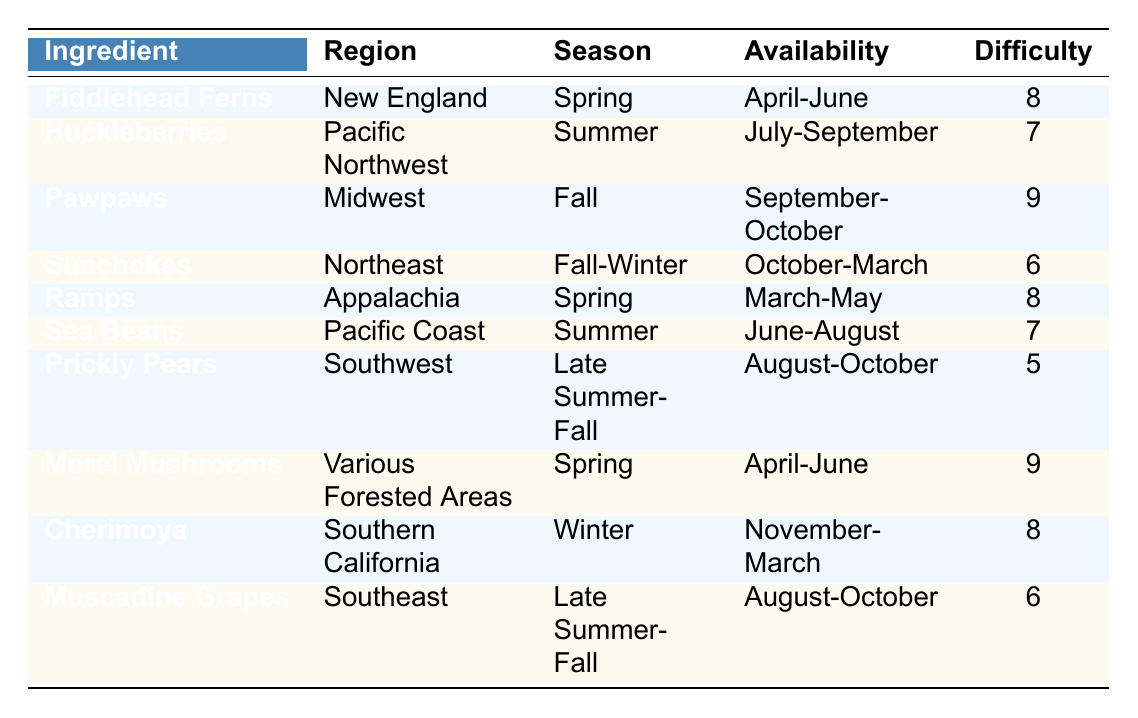What is the season for Fiddlehead Ferns? According to the table, Fiddlehead Ferns are in season in the Spring.
Answer: Spring During which months are Huckleberries available? The table states that Huckleberries are available from July to September.
Answer: July-September What region is associated with Pawpaws? The table specifies the region for Pawpaws as the Midwest.
Answer: Midwest Which ingredient has the highest difficulty rating? By reviewing the table, Morel Mushrooms and Pawpaws both have the highest difficulty rating of 9.
Answer: Morel Mushrooms, Pawpaws Are Sea Beans available in the Spring? The table indicates that Sea Beans are in season during the Summer months (June-August), so the answer is no.
Answer: No What is the availability range for Cherimoya? The table indicates that Cherimoya is available from November to March.
Answer: November-March Which ingredient is available in the Fall season? The table shows Pawpaws, Sunchokes, and Muscadine Grapes are available during Fall months.
Answer: Pawpaws, Sunchokes, Muscadine Grapes How many ingredients are in the table with a difficulty rating of 7? Upon checking the table, Huckleberries and Sea Beans both have a difficulty rating of 7, which totals to 2 ingredients.
Answer: 2 What are the availability months for Sunchokes? The table lists Sunchokes as being available from October to March.
Answer: October-March Which two ingredients share the same availability months of August to October? The table shows that both Prickly Pears and Muscadine Grapes are available during the months of August to October.
Answer: Prickly Pears, Muscadine Grapes What is the average difficulty rating for ingredients available in the Fall? Reviewing the Fall ingredients (Pawpaws, Sunchokes, Muscadine Grapes) gives ratings of 9, 6, and 6. The average is (9 + 6 + 6) / 3 = 7.
Answer: 7 